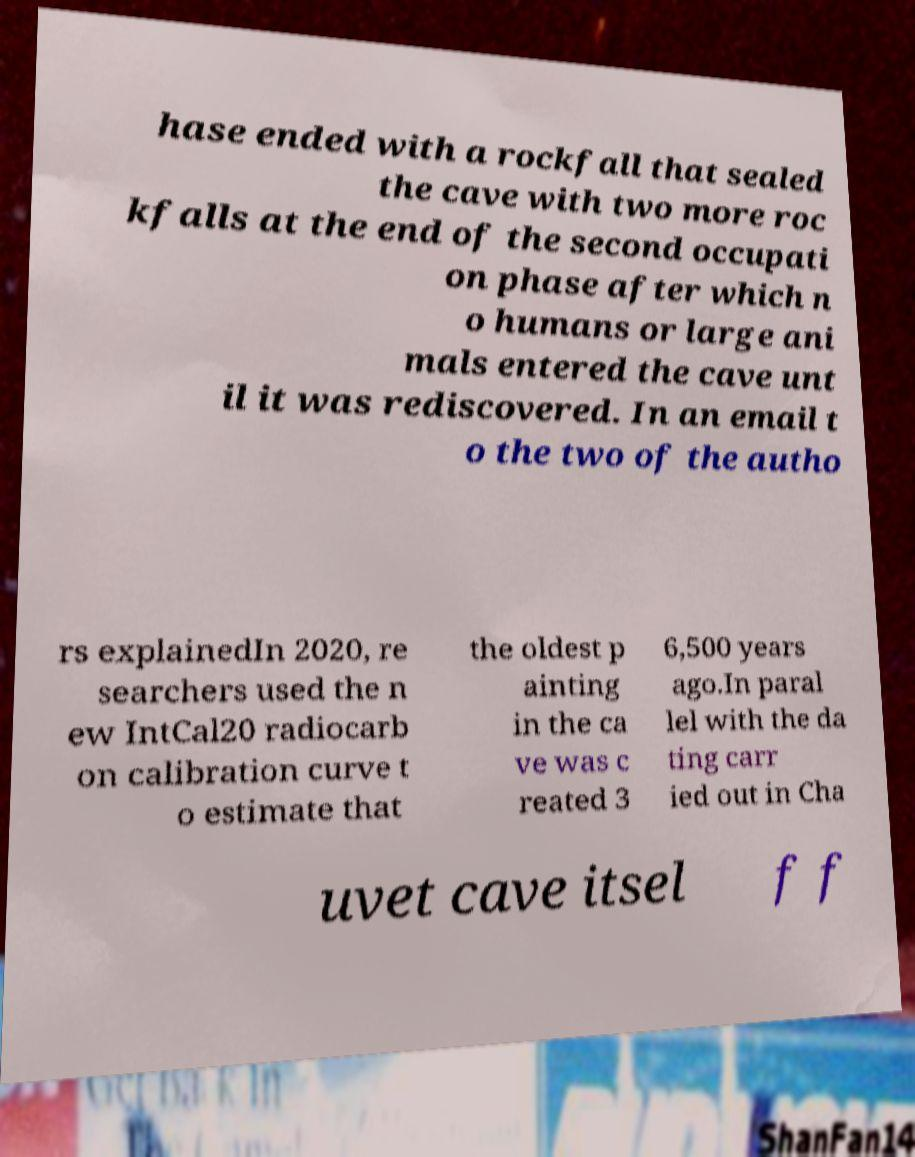Can you read and provide the text displayed in the image?This photo seems to have some interesting text. Can you extract and type it out for me? hase ended with a rockfall that sealed the cave with two more roc kfalls at the end of the second occupati on phase after which n o humans or large ani mals entered the cave unt il it was rediscovered. In an email t o the two of the autho rs explainedIn 2020, re searchers used the n ew IntCal20 radiocarb on calibration curve t o estimate that the oldest p ainting in the ca ve was c reated 3 6,500 years ago.In paral lel with the da ting carr ied out in Cha uvet cave itsel f f 